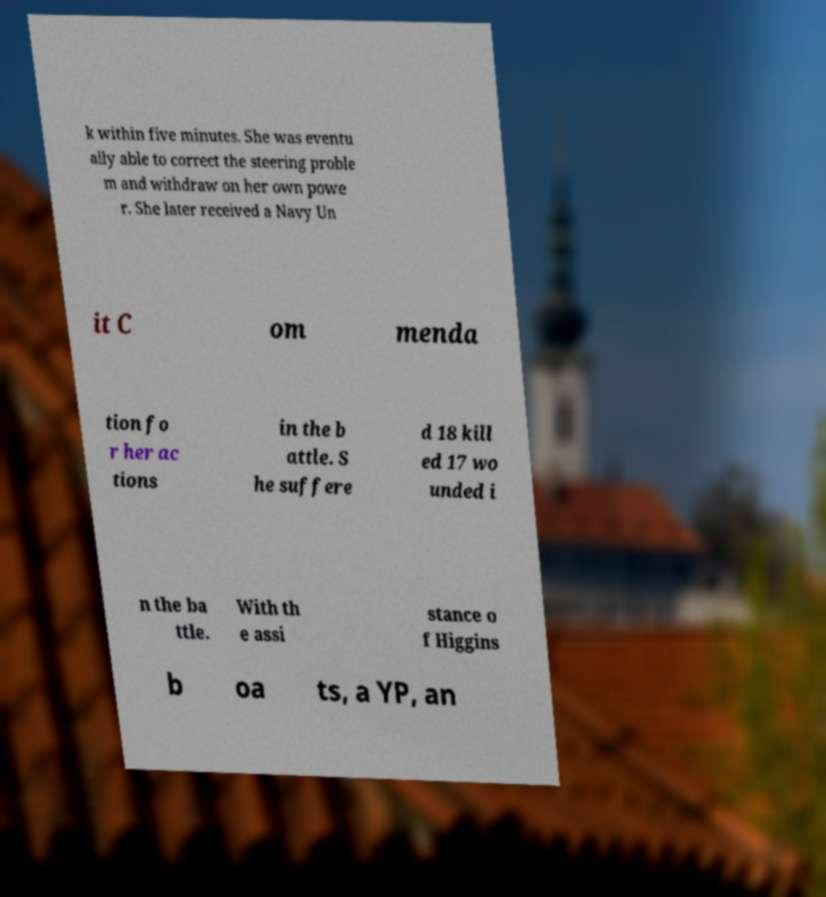Please read and relay the text visible in this image. What does it say? k within five minutes. She was eventu ally able to correct the steering proble m and withdraw on her own powe r. She later received a Navy Un it C om menda tion fo r her ac tions in the b attle. S he suffere d 18 kill ed 17 wo unded i n the ba ttle. With th e assi stance o f Higgins b oa ts, a YP, an 